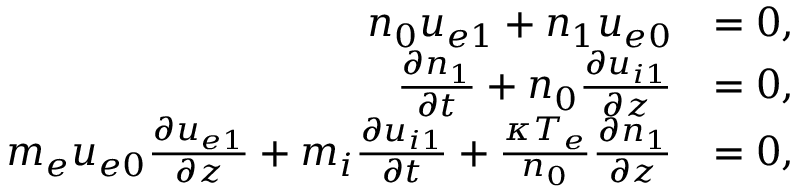<formula> <loc_0><loc_0><loc_500><loc_500>\begin{array} { r l } { n _ { 0 } u _ { e 1 } + n _ { 1 } u _ { e 0 } } & { = 0 , } \\ { \frac { \partial n _ { 1 } } { \partial t } + n _ { 0 } \frac { \partial u _ { i 1 } } { \partial z } } & { = 0 , } \\ { m _ { e } u _ { e 0 } \frac { \partial u _ { e 1 } } { \partial z } + m _ { i } \frac { \partial u _ { i 1 } } { \partial t } + \frac { \kappa T _ { e } } { n _ { 0 } } \frac { \partial n _ { 1 } } { \partial z } } & { = 0 , } \end{array}</formula> 